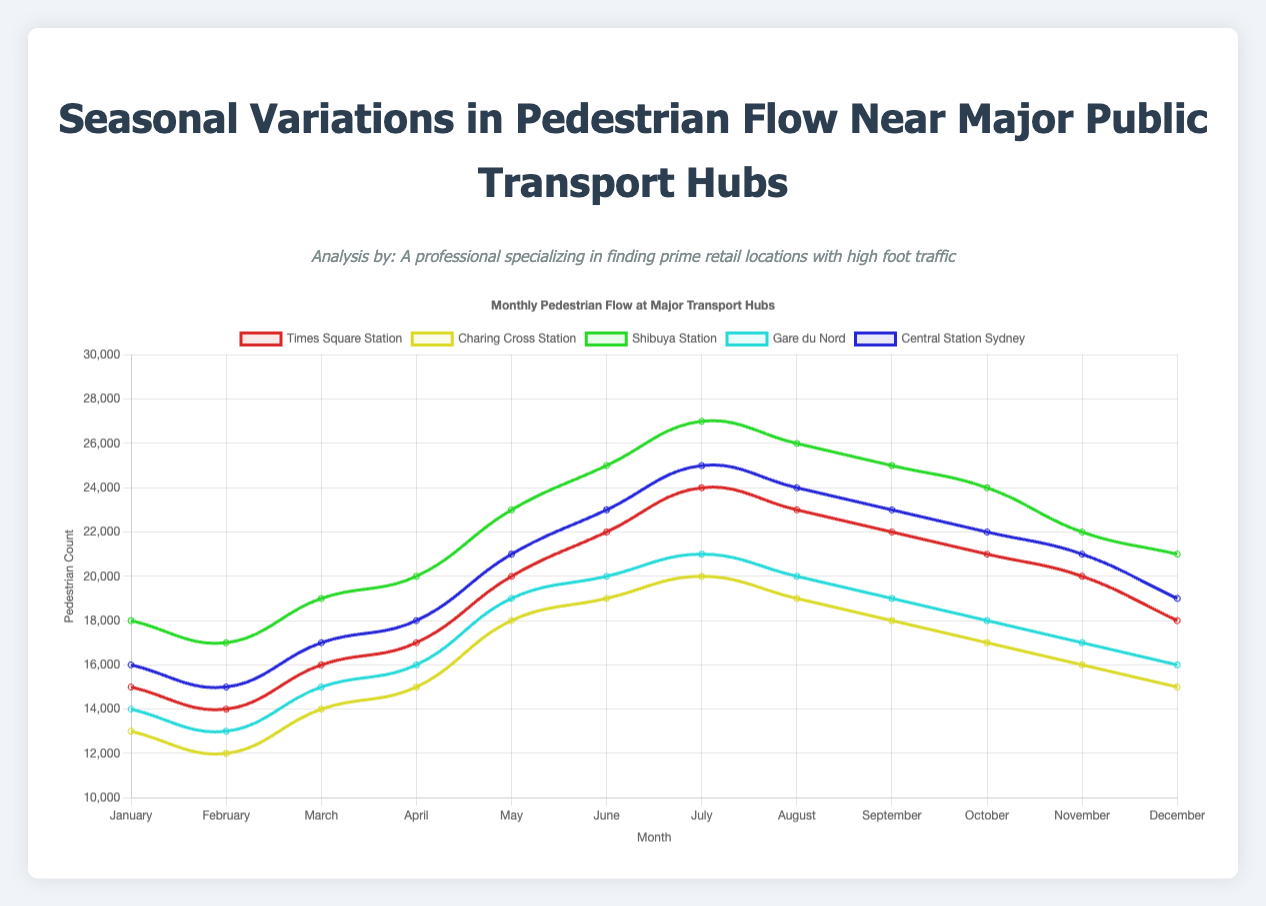Which station had the highest pedestrian flow in July? To find the highest pedestrian flow in July, look at the July data points for each station. Times Square Station has 24,000, Charing Cross Station has 20,000, Shibuya Station has 27,000, Gare du Nord has 21,000, and Central Station Sydney has 25,000. Shibuya Station has the highest value.
Answer: Shibuya Station Between Times Square Station and Charing Cross Station, which had a higher average pedestrian count during Winter? To compare the average counts during Winter, calculate the average for both stations. Times Square's Winter average: (15000 + 14000 + 16000) / 3 = 15000. Charing Cross's Winter average: (13000 + 12000 + 14000) / 3 = 13000. Times Square Station has a higher average.
Answer: Times Square Station During which season did Central Station Sydney have the lowest pedestrian flow? Identify the pedestrian counts for Central Station Sydney for each season and determine the lowest season. Winter: 16000, 15000, 17000. Spring: 18000, 21000, 23000. Summer: 25000, 24000, 23000. Fall: 22000, 21000, 19000. Winter has the lowest values.
Answer: Winter What is the difference in pedestrian flow between Shibuya Station and Gare du Nord in March? Subtract the March pedestrian flow of Gare du Nord from Shibuya Station. Shibuya Station in March: 19000, Gare du Nord in March: 15000. The difference is 19000 - 15000 = 4000.
Answer: 4000 Which station shows the most consistent pedestrian flow throughout the year? To find the most consistent flow, look at the variability in each station's data throughout the year. Charing Cross Station has the smallest range (20000 - 12000 = 8000) compared to others.
Answer: Charing Cross Station In which month does Times Square Station experience the highest foot traffic, and what is the count? Identify the maximum value for Times Square Station across all months. The highest value is in July with 24000.
Answer: July and 24000 How does the summer average pedestrian flow of Gare du Nord compare to the winter average of Shibuya Station? Calculate the summer average for Gare du Nord: (21000 + 20000 + 19000) / 3 = 20000 and the winter average for Shibuya Station: (18000 + 17000 + 19000) / 3 = 18000. Gare du Nord's summer average is higher.
Answer: Gare du Nord’s summer average is higher What was the total pedestrian flow at Charing Cross Station for the entire year? Sum all monthly pedestrian counts for Charing Cross Station. 13000 + 12000 + 14000 + 15000 + 18000 + 19000 + 20000 + 19000 + 18000 + 17000 + 16000 + 15000 = 206000.
Answer: 206000 Which station sees a significant increase in pedestrian flow from February to March? Compare the February and March counts for each station. Shibuya Station has an increase from 17000 to 19000, which is the most significant rise (2000).
Answer: Shibuya Station 